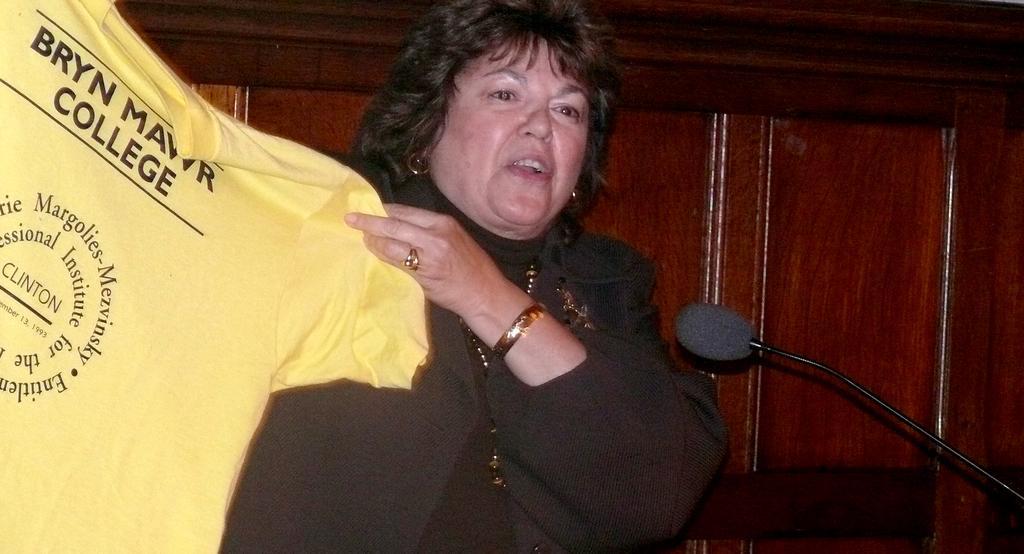Can you describe this image briefly? In this image there is a woman in the middle who is holding the yellow color t-shirt. In front of her there is a mic. In the background there is a wooden wall. 